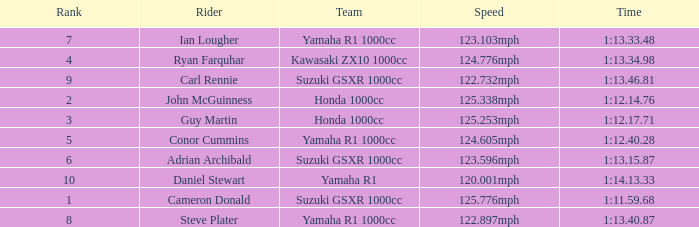What time did team kawasaki zx10 1000cc have? 1:13.34.98. 